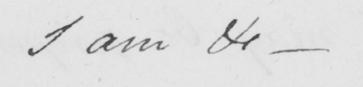What does this handwritten line say? I am &c  _ 